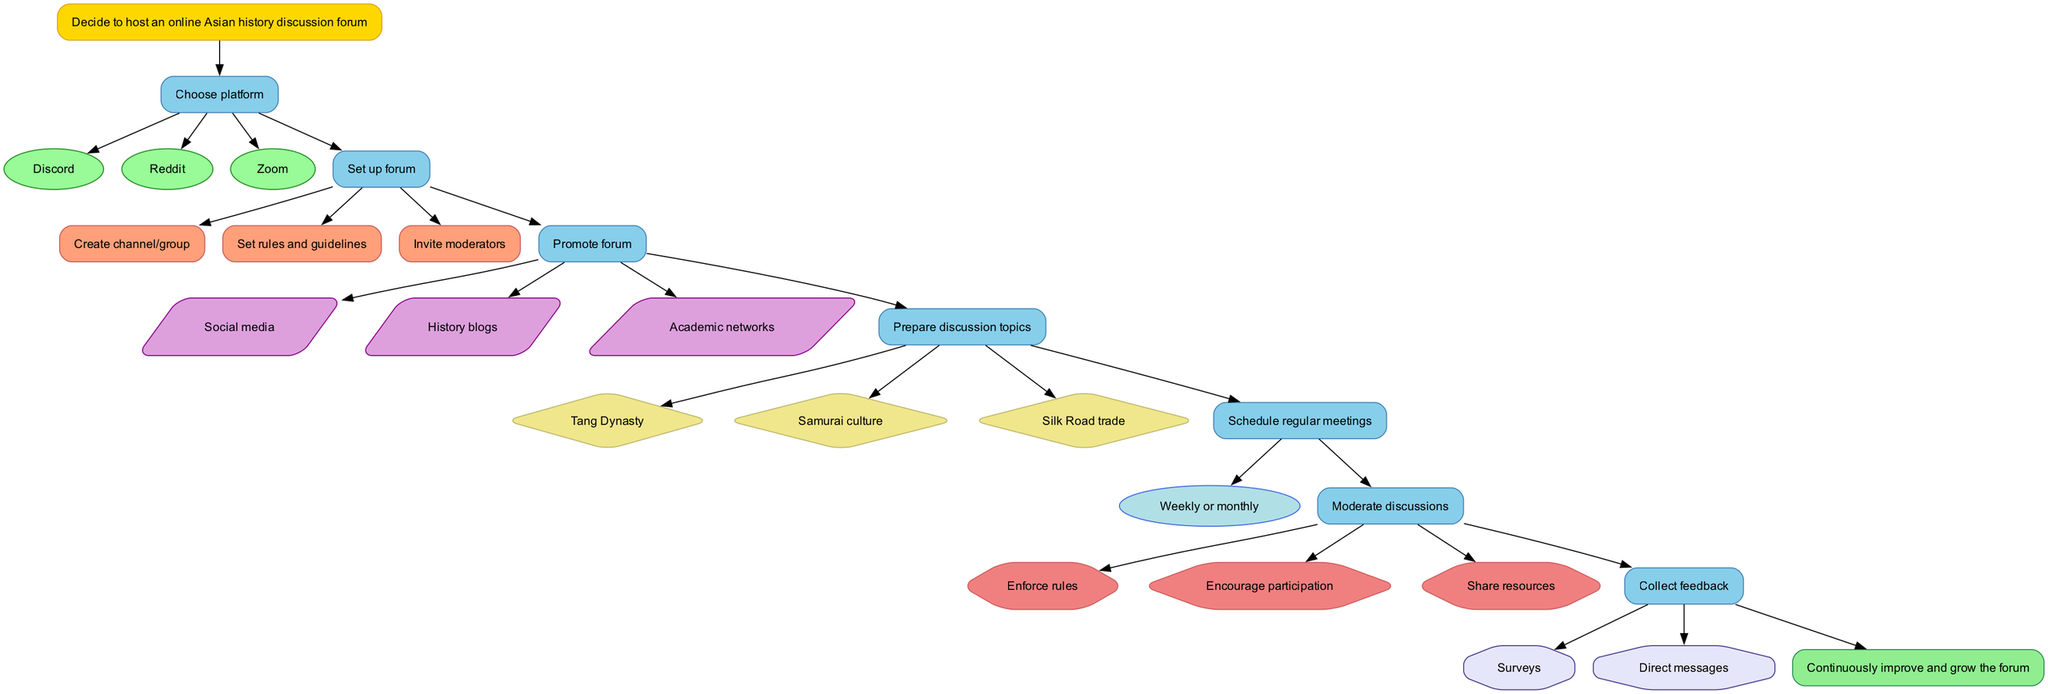What is the starting point of the flowchart? The flowchart begins with the node labeled "Decide to host an online Asian history discussion forum." This is identified as the "start" node in the diagram.
Answer: Decide to host an online Asian history discussion forum How many platforms can be chosen for the forum? The step labeled "Choose platform" lists three options: Discord, Reddit, and Zoom. Therefore, the total number of platforms is three.
Answer: 3 What is the frequency of meetings suggested in the flowchart? The step labeled "Schedule regular meetings" specifies that meetings should occur weekly or monthly. The relevant node mentions this frequency explicitly.
Answer: Weekly or monthly List one method for collecting feedback. The step "Collect feedback" outlines methods and includes options like surveys and direct messages. Either of these can serve as a valid answer to this question.
Answer: Surveys Which step comes directly after "Promote forum"? Following the "Promote forum" step, the next step is "Prepare discussion topics." The edges connecting these two nodes clarify this sequential relationship.
Answer: Prepare discussion topics What actions are involved in moderating discussions? The step "Moderate discussions" details several actions, specifically enforcing rules, encouraging participation, and sharing resources. These are explicitly listed as part of this step.
Answer: Enforce rules, encourage participation, share resources What is the final outcome depicted in the flowchart? The end of the flowchart is represented by the node labeled "Continuously improve and grow the forum." This is specified in the end node, indicating the ultimate goal of the discussed process.
Answer: Continuously improve and grow the forum How many tasks need to be completed to set up the forum? The step "Set up forum" contains three distinct tasks: Create channel/group, set rules and guidelines, and invite moderators. Simply counting these listed tasks provides the answer.
Answer: 3 In which step is the topic "Samurai culture" introduced? The topic "Samurai culture" is mentioned as an example in the step "Prepare discussion topics." This relationship is drawn from the specifics provided within that node.
Answer: Prepare discussion topics 